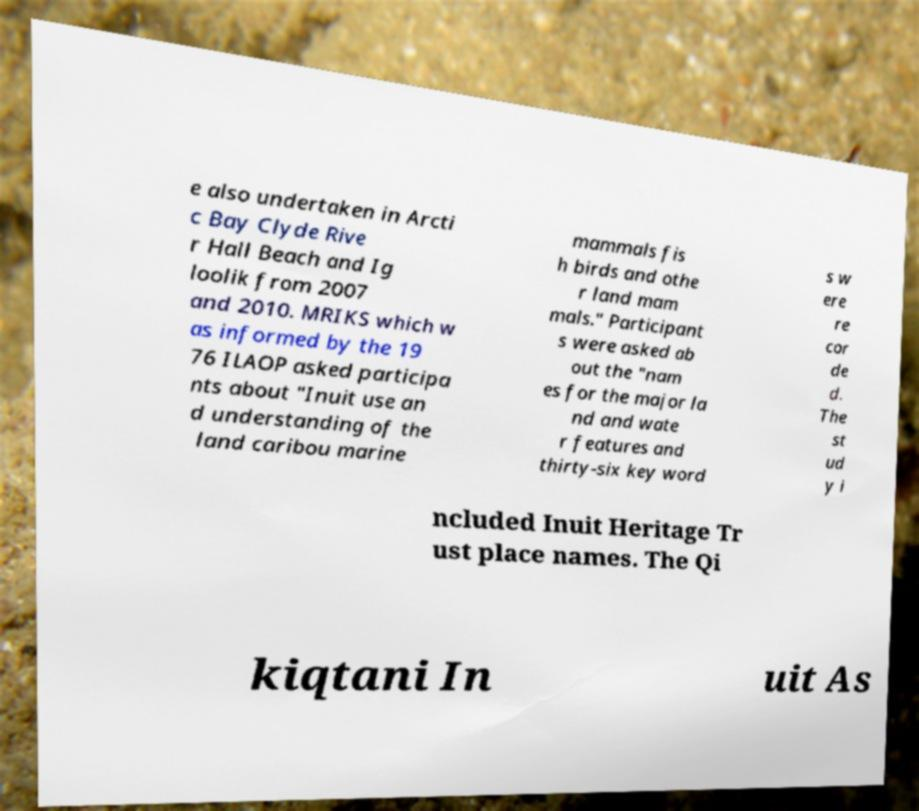Could you assist in decoding the text presented in this image and type it out clearly? e also undertaken in Arcti c Bay Clyde Rive r Hall Beach and Ig loolik from 2007 and 2010. MRIKS which w as informed by the 19 76 ILAOP asked participa nts about "Inuit use an d understanding of the land caribou marine mammals fis h birds and othe r land mam mals." Participant s were asked ab out the "nam es for the major la nd and wate r features and thirty-six key word s w ere re cor de d. The st ud y i ncluded Inuit Heritage Tr ust place names. The Qi kiqtani In uit As 